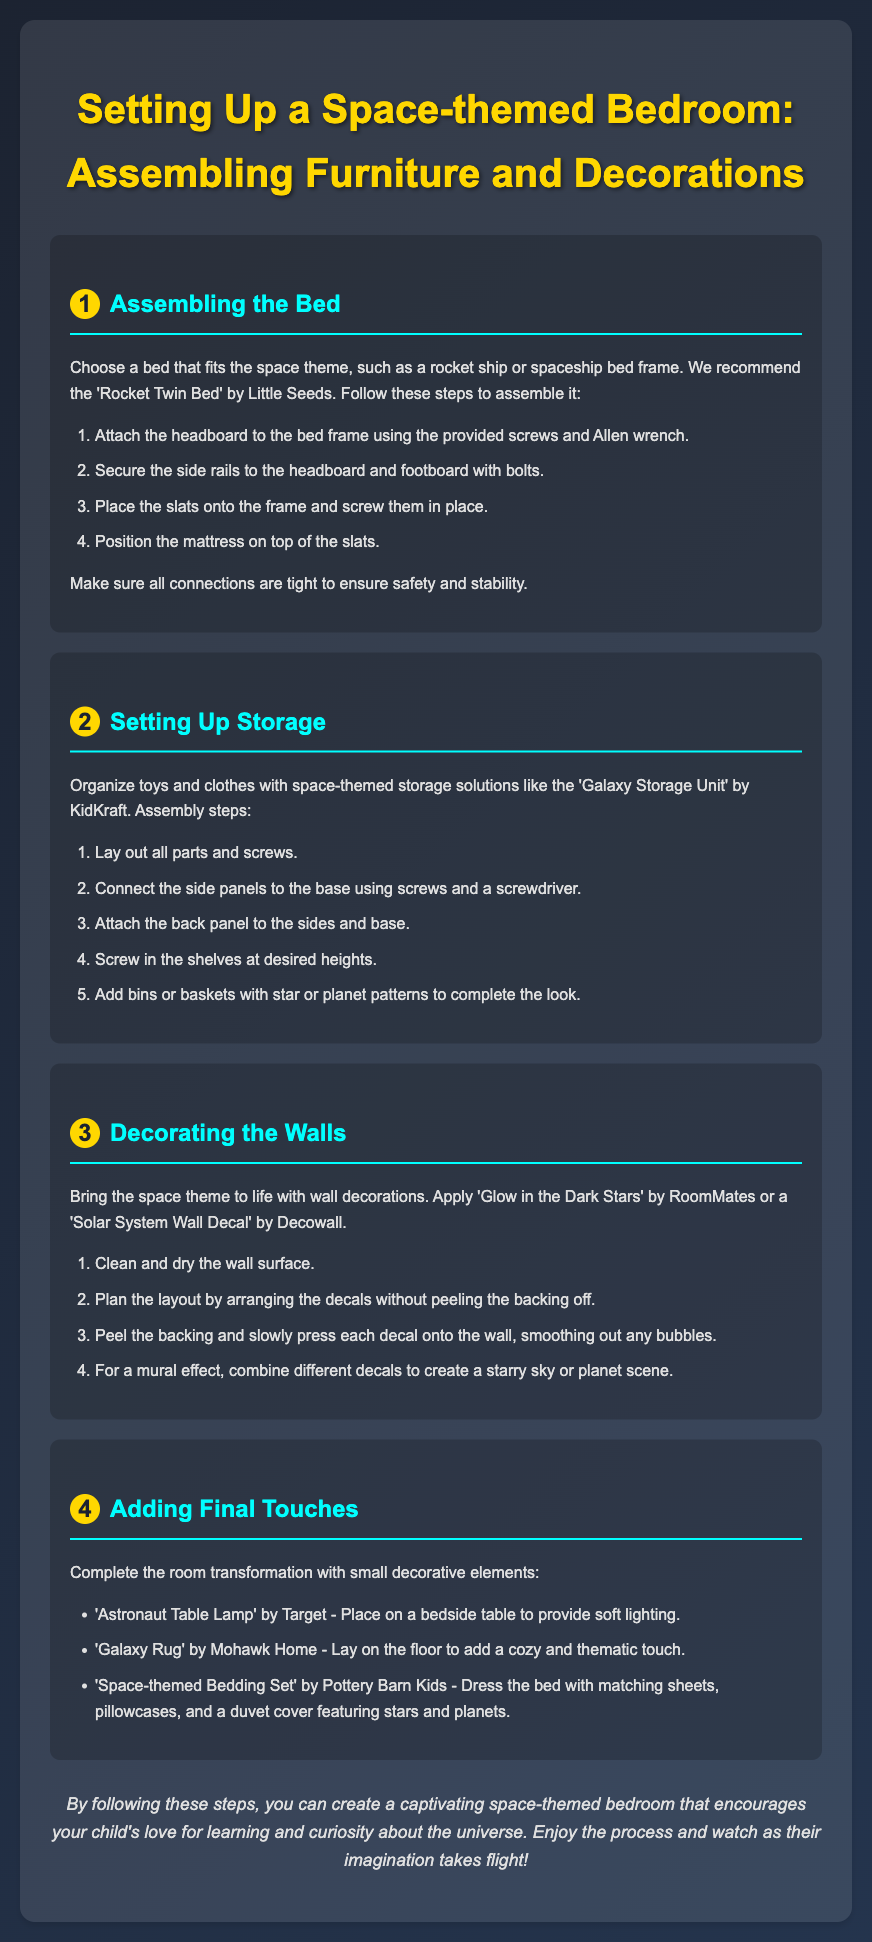What is the theme of the bedroom? The document focuses on setting up a bedroom that is designed around a particular theme, which is space.
Answer: space What is the name of the recommended bed frame? The document specifically mentions a 'Rocket Twin Bed' as a suggestion for the bed frame.
Answer: Rocket Twin Bed What is the first step in assembling the bed? The document outlines step-by-step instructions, with the first step being to attach the headboard to the bed frame.
Answer: Attach the headboard How many steps are included in the wall decoration section? The wall decoration section provides a total of four steps for the decoration process.
Answer: 4 What type of rug is suggested for the bedroom? A 'Galaxy Rug' is recommended to add a thematic touch to the room.
Answer: Galaxy Rug What tool is required to secure the side rails to the bed? The document states that bolts are used to connect the side rails to the headboard and footboard.
Answer: bolts Which item should be placed on the bedside table? The assembly instructions suggest placing an 'Astronaut Table Lamp' on the bedside table for lighting.
Answer: Astronaut Table Lamp Which assembly step involves planning the layout of decals? The planning of the layout is mentioned as the second step in the wall decoration section.
Answer: second step What is the purpose of the room transformation process? The conclusion of the document highlights the importance of the transformation in promoting a love for learning and curiosity about the universe.
Answer: encourages curiosity 